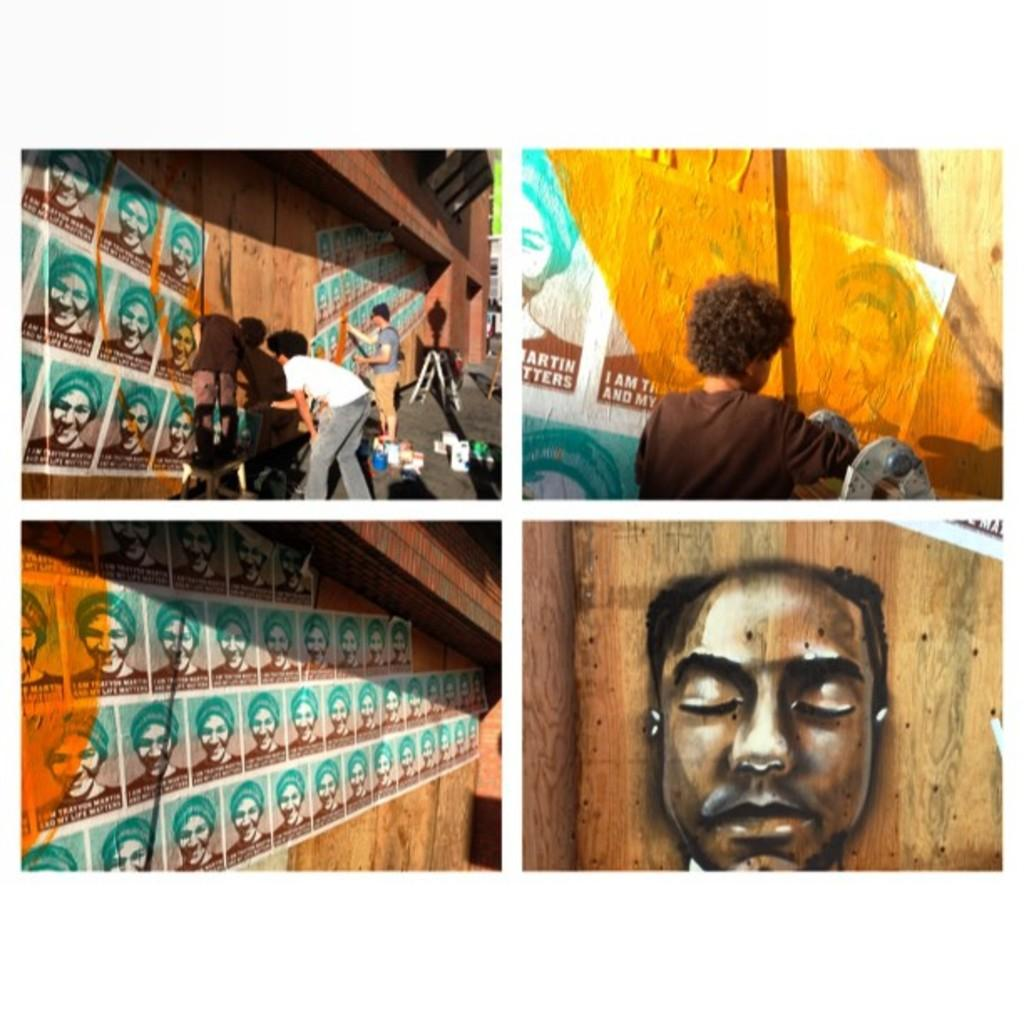How many people are in the image? There are persons in the image, but the exact number is not specified. What can be seen on the wall in the image? There are posters on a wall in the image. What objects are present in the image that can hold liquids? There are buckets in the image that can hold liquids. What type of structure is visible in the image? There is a wall in the image. What type of cushion is being used to support the wire in the image? There is no cushion or wire present in the image. What type of skin condition can be seen on the persons in the image? The facts provided do not mention any skin conditions or details about the persons' skin. 